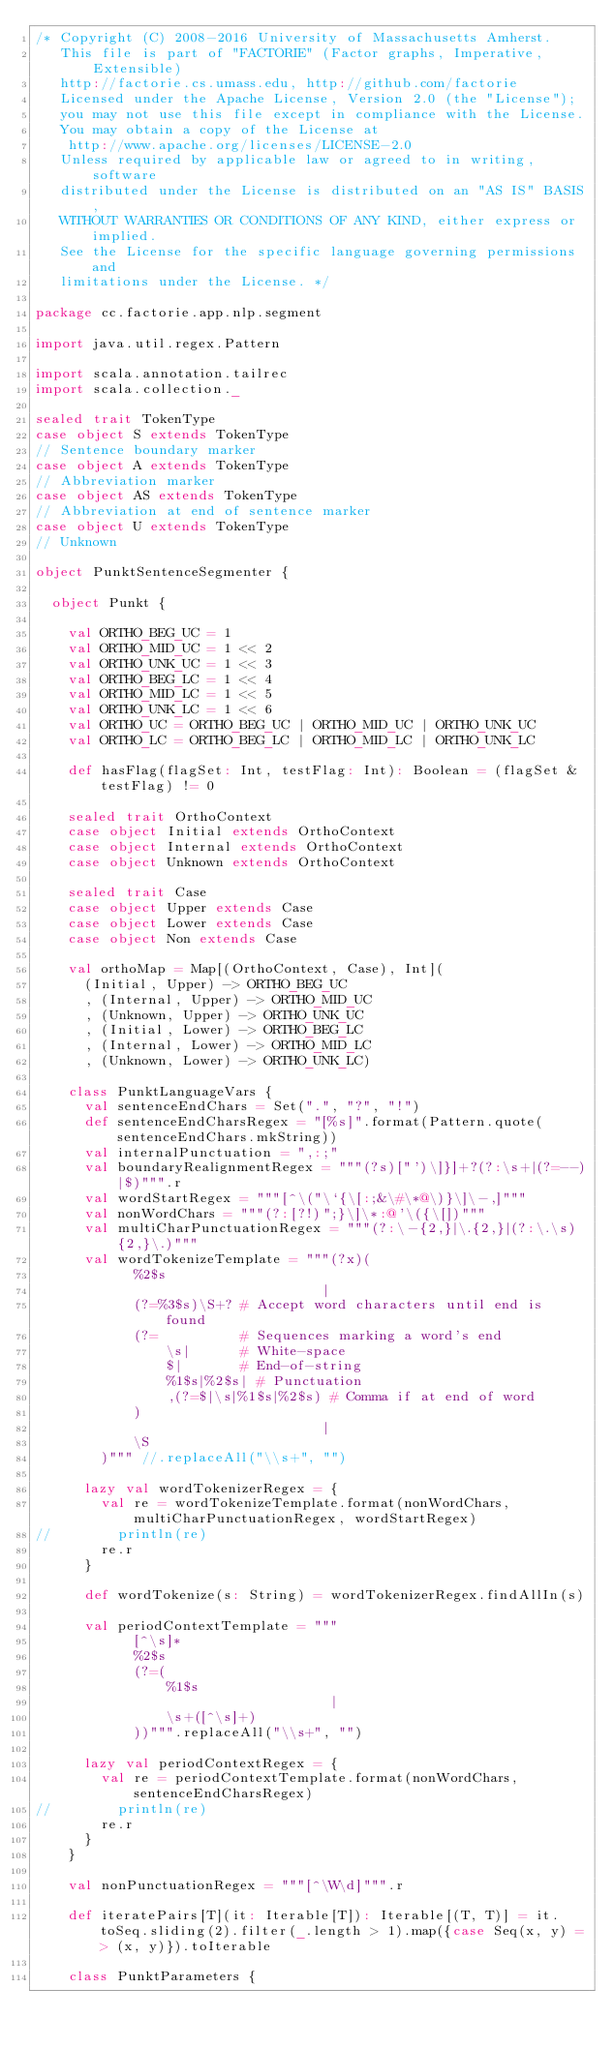Convert code to text. <code><loc_0><loc_0><loc_500><loc_500><_Scala_>/* Copyright (C) 2008-2016 University of Massachusetts Amherst.
   This file is part of "FACTORIE" (Factor graphs, Imperative, Extensible)
   http://factorie.cs.umass.edu, http://github.com/factorie
   Licensed under the Apache License, Version 2.0 (the "License");
   you may not use this file except in compliance with the License.
   You may obtain a copy of the License at
    http://www.apache.org/licenses/LICENSE-2.0
   Unless required by applicable law or agreed to in writing, software
   distributed under the License is distributed on an "AS IS" BASIS,
   WITHOUT WARRANTIES OR CONDITIONS OF ANY KIND, either express or implied.
   See the License for the specific language governing permissions and
   limitations under the License. */

package cc.factorie.app.nlp.segment

import java.util.regex.Pattern

import scala.annotation.tailrec
import scala.collection._

sealed trait TokenType
case object S extends TokenType
// Sentence boundary marker
case object A extends TokenType
// Abbreviation marker
case object AS extends TokenType
// Abbreviation at end of sentence marker
case object U extends TokenType
// Unknown

object PunktSentenceSegmenter {

  object Punkt {

    val ORTHO_BEG_UC = 1
    val ORTHO_MID_UC = 1 << 2
    val ORTHO_UNK_UC = 1 << 3
    val ORTHO_BEG_LC = 1 << 4
    val ORTHO_MID_LC = 1 << 5
    val ORTHO_UNK_LC = 1 << 6
    val ORTHO_UC = ORTHO_BEG_UC | ORTHO_MID_UC | ORTHO_UNK_UC
    val ORTHO_LC = ORTHO_BEG_LC | ORTHO_MID_LC | ORTHO_UNK_LC

    def hasFlag(flagSet: Int, testFlag: Int): Boolean = (flagSet & testFlag) != 0

    sealed trait OrthoContext
    case object Initial extends OrthoContext
    case object Internal extends OrthoContext
    case object Unknown extends OrthoContext

    sealed trait Case
    case object Upper extends Case
    case object Lower extends Case
    case object Non extends Case

    val orthoMap = Map[(OrthoContext, Case), Int](
      (Initial, Upper) -> ORTHO_BEG_UC
      , (Internal, Upper) -> ORTHO_MID_UC
      , (Unknown, Upper) -> ORTHO_UNK_UC
      , (Initial, Lower) -> ORTHO_BEG_LC
      , (Internal, Lower) -> ORTHO_MID_LC
      , (Unknown, Lower) -> ORTHO_UNK_LC)

    class PunktLanguageVars {
      val sentenceEndChars = Set(".", "?", "!")
      def sentenceEndCharsRegex = "[%s]".format(Pattern.quote(sentenceEndChars.mkString))
      val internalPunctuation = ",:;"
      val boundaryRealignmentRegex = """(?s)["')\]}]+?(?:\s+|(?=--)|$)""".r
      val wordStartRegex = """[^\("\`{\[:;&\#\*@\)}\]\-,]"""
      val nonWordChars = """(?:[?!)";}\]\*:@'\({\[])"""
      val multiCharPunctuationRegex = """(?:\-{2,}|\.{2,}|(?:\.\s){2,}\.)"""
      val wordTokenizeTemplate = """(?x)(
            %2$s
                                   |
            (?=%3$s)\S+? # Accept word characters until end is found
            (?=          # Sequences marking a word's end
                \s|      # White-space
                $|       # End-of-string
                %1$s|%2$s| # Punctuation
                ,(?=$|\s|%1$s|%2$s) # Comma if at end of word
            )
                                   |
            \S
        )""" //.replaceAll("\\s+", "")

      lazy val wordTokenizerRegex = {
        val re = wordTokenizeTemplate.format(nonWordChars, multiCharPunctuationRegex, wordStartRegex)
//        println(re)
        re.r
      }

      def wordTokenize(s: String) = wordTokenizerRegex.findAllIn(s)

      val periodContextTemplate = """
            [^\s]*
            %2$s
            (?=(
                %1$s
                                    |
                \s+([^\s]+)
            ))""".replaceAll("\\s+", "")

      lazy val periodContextRegex = {
        val re = periodContextTemplate.format(nonWordChars, sentenceEndCharsRegex)
//        println(re)
        re.r
      }
    }

    val nonPunctuationRegex = """[^\W\d]""".r

    def iteratePairs[T](it: Iterable[T]): Iterable[(T, T)] = it.toSeq.sliding(2).filter(_.length > 1).map({case Seq(x, y) => (x, y)}).toIterable

    class PunktParameters {</code> 